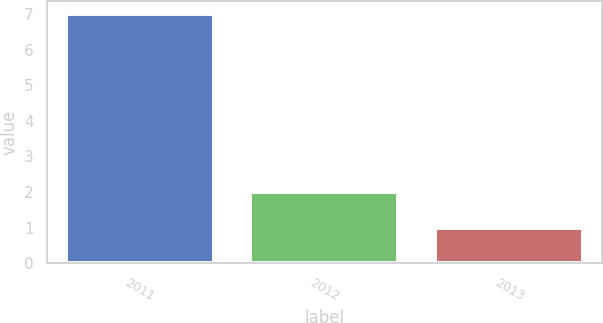<chart> <loc_0><loc_0><loc_500><loc_500><bar_chart><fcel>2011<fcel>2012<fcel>2013<nl><fcel>7<fcel>2<fcel>1<nl></chart> 